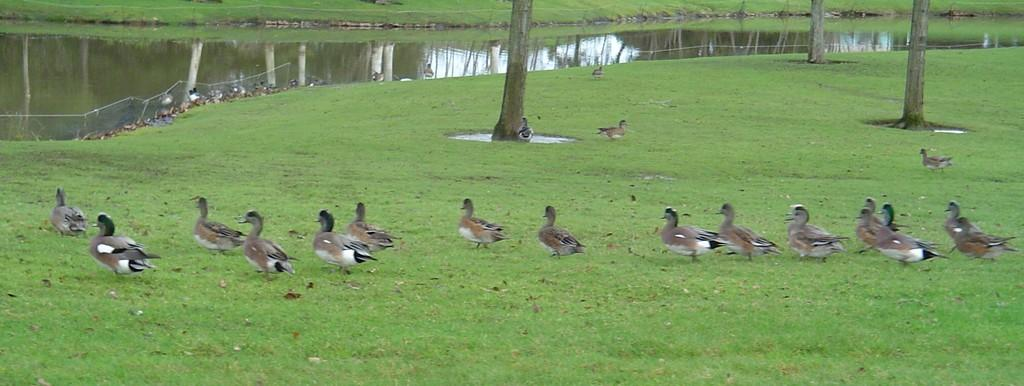What type of animals can be seen in the image? There are ducks in the image. What are the ducks doing in the image? The ducks are walking on the grass in the image. What can be seen in the background of the image? There is water visible in the image. What type of vegetation is present in the image? There are tree trunks in the image. What vein is visible in the image? There is no vein visible in the image; it features ducks walking on the grass and water with tree trunks in the background. 